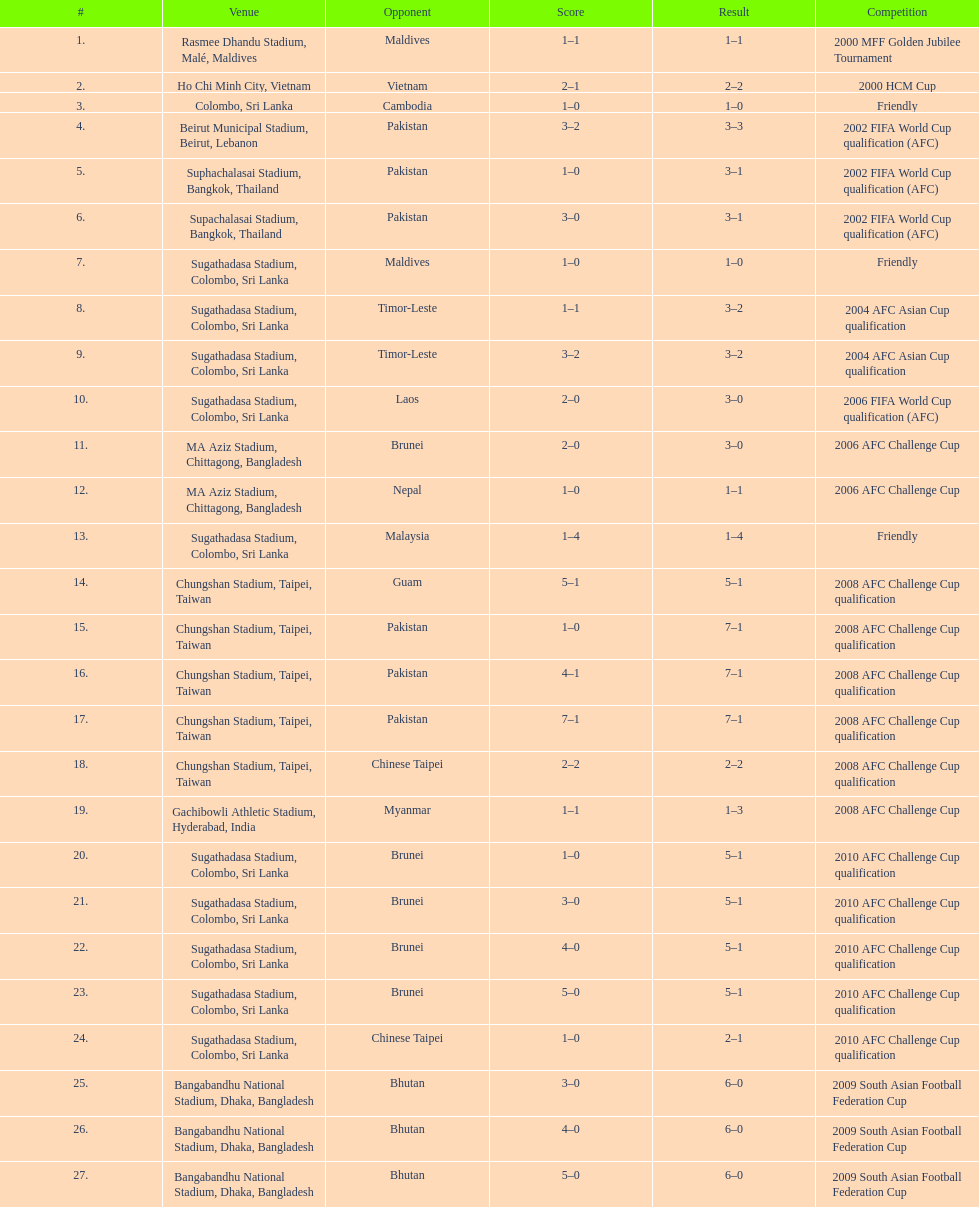Were more competitions played in april or december? April. 